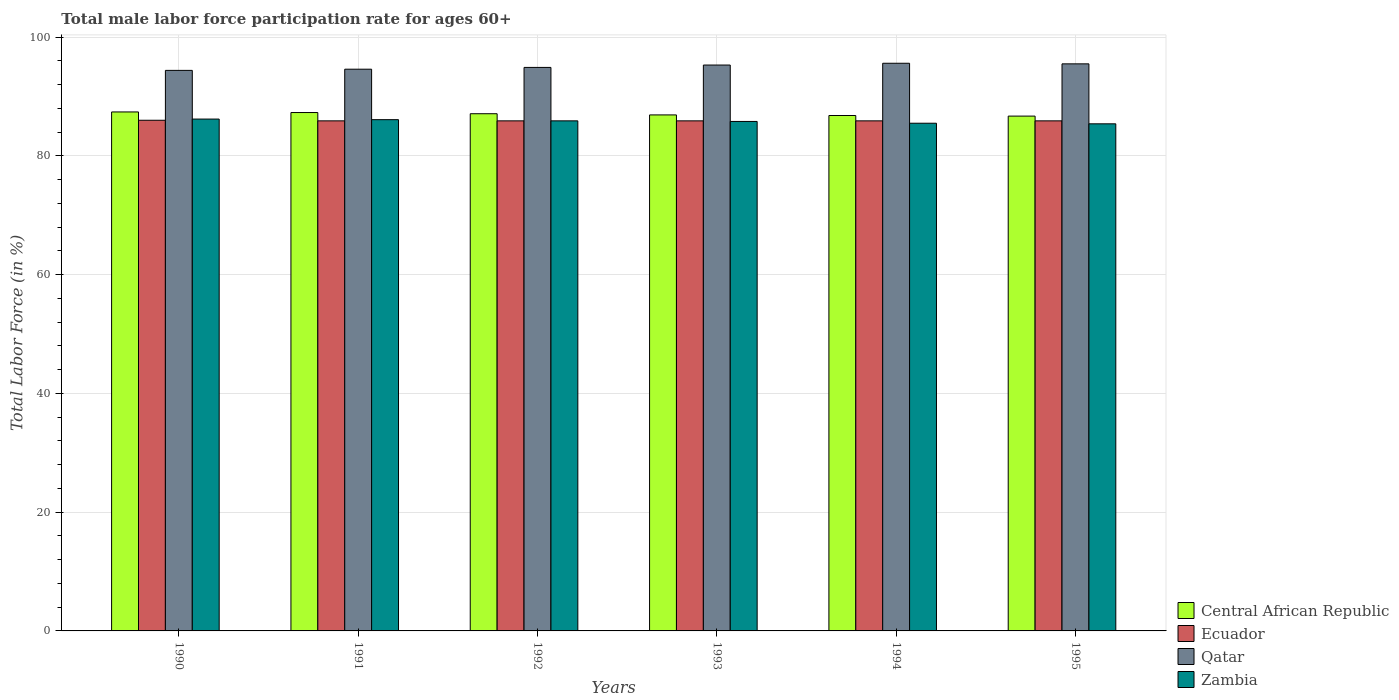How many different coloured bars are there?
Your response must be concise. 4. How many groups of bars are there?
Your response must be concise. 6. Are the number of bars per tick equal to the number of legend labels?
Your answer should be compact. Yes. Are the number of bars on each tick of the X-axis equal?
Your response must be concise. Yes. How many bars are there on the 3rd tick from the left?
Give a very brief answer. 4. What is the label of the 5th group of bars from the left?
Your answer should be very brief. 1994. What is the male labor force participation rate in Zambia in 1990?
Provide a succinct answer. 86.2. Across all years, what is the maximum male labor force participation rate in Central African Republic?
Provide a short and direct response. 87.4. Across all years, what is the minimum male labor force participation rate in Central African Republic?
Ensure brevity in your answer.  86.7. In which year was the male labor force participation rate in Central African Republic maximum?
Your answer should be very brief. 1990. In which year was the male labor force participation rate in Qatar minimum?
Your response must be concise. 1990. What is the total male labor force participation rate in Qatar in the graph?
Offer a very short reply. 570.3. What is the difference between the male labor force participation rate in Qatar in 1990 and that in 1994?
Offer a very short reply. -1.2. What is the average male labor force participation rate in Zambia per year?
Provide a succinct answer. 85.82. In the year 1992, what is the difference between the male labor force participation rate in Zambia and male labor force participation rate in Ecuador?
Offer a very short reply. 0. What is the ratio of the male labor force participation rate in Qatar in 1990 to that in 1991?
Give a very brief answer. 1. What is the difference between the highest and the second highest male labor force participation rate in Ecuador?
Provide a succinct answer. 0.1. What is the difference between the highest and the lowest male labor force participation rate in Zambia?
Your answer should be compact. 0.8. In how many years, is the male labor force participation rate in Qatar greater than the average male labor force participation rate in Qatar taken over all years?
Your answer should be compact. 3. Is the sum of the male labor force participation rate in Central African Republic in 1991 and 1995 greater than the maximum male labor force participation rate in Zambia across all years?
Ensure brevity in your answer.  Yes. What does the 2nd bar from the left in 1991 represents?
Keep it short and to the point. Ecuador. What does the 3rd bar from the right in 1991 represents?
Keep it short and to the point. Ecuador. How many bars are there?
Keep it short and to the point. 24. Are all the bars in the graph horizontal?
Provide a succinct answer. No. What is the difference between two consecutive major ticks on the Y-axis?
Ensure brevity in your answer.  20. Are the values on the major ticks of Y-axis written in scientific E-notation?
Keep it short and to the point. No. Does the graph contain any zero values?
Offer a very short reply. No. Where does the legend appear in the graph?
Your answer should be compact. Bottom right. How are the legend labels stacked?
Your response must be concise. Vertical. What is the title of the graph?
Your answer should be very brief. Total male labor force participation rate for ages 60+. Does "Israel" appear as one of the legend labels in the graph?
Keep it short and to the point. No. What is the label or title of the X-axis?
Provide a succinct answer. Years. What is the Total Labor Force (in %) of Central African Republic in 1990?
Make the answer very short. 87.4. What is the Total Labor Force (in %) in Ecuador in 1990?
Ensure brevity in your answer.  86. What is the Total Labor Force (in %) of Qatar in 1990?
Make the answer very short. 94.4. What is the Total Labor Force (in %) in Zambia in 1990?
Keep it short and to the point. 86.2. What is the Total Labor Force (in %) of Central African Republic in 1991?
Keep it short and to the point. 87.3. What is the Total Labor Force (in %) in Ecuador in 1991?
Your response must be concise. 85.9. What is the Total Labor Force (in %) in Qatar in 1991?
Make the answer very short. 94.6. What is the Total Labor Force (in %) in Zambia in 1991?
Your answer should be compact. 86.1. What is the Total Labor Force (in %) in Central African Republic in 1992?
Provide a succinct answer. 87.1. What is the Total Labor Force (in %) in Ecuador in 1992?
Your answer should be compact. 85.9. What is the Total Labor Force (in %) in Qatar in 1992?
Your response must be concise. 94.9. What is the Total Labor Force (in %) in Zambia in 1992?
Your answer should be very brief. 85.9. What is the Total Labor Force (in %) of Central African Republic in 1993?
Provide a succinct answer. 86.9. What is the Total Labor Force (in %) in Ecuador in 1993?
Your answer should be very brief. 85.9. What is the Total Labor Force (in %) in Qatar in 1993?
Give a very brief answer. 95.3. What is the Total Labor Force (in %) in Zambia in 1993?
Offer a terse response. 85.8. What is the Total Labor Force (in %) of Central African Republic in 1994?
Keep it short and to the point. 86.8. What is the Total Labor Force (in %) in Ecuador in 1994?
Make the answer very short. 85.9. What is the Total Labor Force (in %) in Qatar in 1994?
Give a very brief answer. 95.6. What is the Total Labor Force (in %) of Zambia in 1994?
Your response must be concise. 85.5. What is the Total Labor Force (in %) of Central African Republic in 1995?
Provide a short and direct response. 86.7. What is the Total Labor Force (in %) of Ecuador in 1995?
Offer a terse response. 85.9. What is the Total Labor Force (in %) of Qatar in 1995?
Make the answer very short. 95.5. What is the Total Labor Force (in %) of Zambia in 1995?
Keep it short and to the point. 85.4. Across all years, what is the maximum Total Labor Force (in %) of Central African Republic?
Your answer should be compact. 87.4. Across all years, what is the maximum Total Labor Force (in %) in Ecuador?
Your answer should be compact. 86. Across all years, what is the maximum Total Labor Force (in %) in Qatar?
Offer a very short reply. 95.6. Across all years, what is the maximum Total Labor Force (in %) of Zambia?
Offer a terse response. 86.2. Across all years, what is the minimum Total Labor Force (in %) of Central African Republic?
Your answer should be very brief. 86.7. Across all years, what is the minimum Total Labor Force (in %) of Ecuador?
Give a very brief answer. 85.9. Across all years, what is the minimum Total Labor Force (in %) in Qatar?
Provide a short and direct response. 94.4. Across all years, what is the minimum Total Labor Force (in %) of Zambia?
Your answer should be compact. 85.4. What is the total Total Labor Force (in %) in Central African Republic in the graph?
Offer a very short reply. 522.2. What is the total Total Labor Force (in %) of Ecuador in the graph?
Provide a short and direct response. 515.5. What is the total Total Labor Force (in %) of Qatar in the graph?
Keep it short and to the point. 570.3. What is the total Total Labor Force (in %) in Zambia in the graph?
Your answer should be very brief. 514.9. What is the difference between the Total Labor Force (in %) in Ecuador in 1990 and that in 1991?
Give a very brief answer. 0.1. What is the difference between the Total Labor Force (in %) in Ecuador in 1990 and that in 1992?
Your answer should be very brief. 0.1. What is the difference between the Total Labor Force (in %) in Central African Republic in 1990 and that in 1993?
Your answer should be compact. 0.5. What is the difference between the Total Labor Force (in %) in Ecuador in 1990 and that in 1993?
Give a very brief answer. 0.1. What is the difference between the Total Labor Force (in %) in Zambia in 1990 and that in 1993?
Keep it short and to the point. 0.4. What is the difference between the Total Labor Force (in %) of Qatar in 1990 and that in 1994?
Offer a very short reply. -1.2. What is the difference between the Total Labor Force (in %) of Central African Republic in 1990 and that in 1995?
Offer a terse response. 0.7. What is the difference between the Total Labor Force (in %) of Ecuador in 1990 and that in 1995?
Provide a short and direct response. 0.1. What is the difference between the Total Labor Force (in %) in Zambia in 1990 and that in 1995?
Offer a terse response. 0.8. What is the difference between the Total Labor Force (in %) of Central African Republic in 1991 and that in 1992?
Ensure brevity in your answer.  0.2. What is the difference between the Total Labor Force (in %) of Central African Republic in 1991 and that in 1993?
Provide a short and direct response. 0.4. What is the difference between the Total Labor Force (in %) in Ecuador in 1991 and that in 1993?
Keep it short and to the point. 0. What is the difference between the Total Labor Force (in %) of Central African Republic in 1991 and that in 1994?
Keep it short and to the point. 0.5. What is the difference between the Total Labor Force (in %) in Qatar in 1991 and that in 1994?
Offer a terse response. -1. What is the difference between the Total Labor Force (in %) in Zambia in 1991 and that in 1994?
Provide a short and direct response. 0.6. What is the difference between the Total Labor Force (in %) in Central African Republic in 1991 and that in 1995?
Offer a terse response. 0.6. What is the difference between the Total Labor Force (in %) in Zambia in 1991 and that in 1995?
Your response must be concise. 0.7. What is the difference between the Total Labor Force (in %) of Central African Republic in 1992 and that in 1993?
Ensure brevity in your answer.  0.2. What is the difference between the Total Labor Force (in %) in Ecuador in 1992 and that in 1993?
Your response must be concise. 0. What is the difference between the Total Labor Force (in %) of Qatar in 1992 and that in 1993?
Provide a succinct answer. -0.4. What is the difference between the Total Labor Force (in %) of Central African Republic in 1992 and that in 1994?
Your answer should be compact. 0.3. What is the difference between the Total Labor Force (in %) of Ecuador in 1992 and that in 1994?
Provide a short and direct response. 0. What is the difference between the Total Labor Force (in %) in Zambia in 1992 and that in 1994?
Provide a short and direct response. 0.4. What is the difference between the Total Labor Force (in %) of Central African Republic in 1992 and that in 1995?
Offer a terse response. 0.4. What is the difference between the Total Labor Force (in %) of Ecuador in 1992 and that in 1995?
Your response must be concise. 0. What is the difference between the Total Labor Force (in %) of Zambia in 1992 and that in 1995?
Your response must be concise. 0.5. What is the difference between the Total Labor Force (in %) of Zambia in 1993 and that in 1994?
Ensure brevity in your answer.  0.3. What is the difference between the Total Labor Force (in %) of Qatar in 1993 and that in 1995?
Your response must be concise. -0.2. What is the difference between the Total Labor Force (in %) in Zambia in 1993 and that in 1995?
Your answer should be compact. 0.4. What is the difference between the Total Labor Force (in %) of Central African Republic in 1990 and the Total Labor Force (in %) of Ecuador in 1991?
Your answer should be very brief. 1.5. What is the difference between the Total Labor Force (in %) of Central African Republic in 1990 and the Total Labor Force (in %) of Qatar in 1991?
Give a very brief answer. -7.2. What is the difference between the Total Labor Force (in %) in Central African Republic in 1990 and the Total Labor Force (in %) in Zambia in 1991?
Your response must be concise. 1.3. What is the difference between the Total Labor Force (in %) of Ecuador in 1990 and the Total Labor Force (in %) of Qatar in 1991?
Offer a terse response. -8.6. What is the difference between the Total Labor Force (in %) in Ecuador in 1990 and the Total Labor Force (in %) in Zambia in 1991?
Offer a terse response. -0.1. What is the difference between the Total Labor Force (in %) in Central African Republic in 1990 and the Total Labor Force (in %) in Qatar in 1992?
Your answer should be very brief. -7.5. What is the difference between the Total Labor Force (in %) in Central African Republic in 1990 and the Total Labor Force (in %) in Zambia in 1992?
Offer a very short reply. 1.5. What is the difference between the Total Labor Force (in %) in Ecuador in 1990 and the Total Labor Force (in %) in Qatar in 1992?
Give a very brief answer. -8.9. What is the difference between the Total Labor Force (in %) of Ecuador in 1990 and the Total Labor Force (in %) of Zambia in 1992?
Provide a succinct answer. 0.1. What is the difference between the Total Labor Force (in %) of Qatar in 1990 and the Total Labor Force (in %) of Zambia in 1992?
Your response must be concise. 8.5. What is the difference between the Total Labor Force (in %) in Central African Republic in 1990 and the Total Labor Force (in %) in Ecuador in 1993?
Your answer should be very brief. 1.5. What is the difference between the Total Labor Force (in %) of Central African Republic in 1990 and the Total Labor Force (in %) of Zambia in 1993?
Offer a terse response. 1.6. What is the difference between the Total Labor Force (in %) of Qatar in 1990 and the Total Labor Force (in %) of Zambia in 1993?
Your answer should be compact. 8.6. What is the difference between the Total Labor Force (in %) of Central African Republic in 1990 and the Total Labor Force (in %) of Qatar in 1994?
Make the answer very short. -8.2. What is the difference between the Total Labor Force (in %) of Central African Republic in 1990 and the Total Labor Force (in %) of Zambia in 1994?
Make the answer very short. 1.9. What is the difference between the Total Labor Force (in %) in Ecuador in 1990 and the Total Labor Force (in %) in Qatar in 1994?
Provide a succinct answer. -9.6. What is the difference between the Total Labor Force (in %) in Ecuador in 1990 and the Total Labor Force (in %) in Zambia in 1994?
Provide a succinct answer. 0.5. What is the difference between the Total Labor Force (in %) of Qatar in 1990 and the Total Labor Force (in %) of Zambia in 1994?
Keep it short and to the point. 8.9. What is the difference between the Total Labor Force (in %) in Ecuador in 1990 and the Total Labor Force (in %) in Qatar in 1995?
Your answer should be compact. -9.5. What is the difference between the Total Labor Force (in %) in Ecuador in 1990 and the Total Labor Force (in %) in Zambia in 1995?
Make the answer very short. 0.6. What is the difference between the Total Labor Force (in %) of Qatar in 1990 and the Total Labor Force (in %) of Zambia in 1995?
Ensure brevity in your answer.  9. What is the difference between the Total Labor Force (in %) in Central African Republic in 1991 and the Total Labor Force (in %) in Ecuador in 1992?
Make the answer very short. 1.4. What is the difference between the Total Labor Force (in %) of Central African Republic in 1991 and the Total Labor Force (in %) of Qatar in 1992?
Your answer should be very brief. -7.6. What is the difference between the Total Labor Force (in %) in Central African Republic in 1991 and the Total Labor Force (in %) in Zambia in 1992?
Your response must be concise. 1.4. What is the difference between the Total Labor Force (in %) in Ecuador in 1991 and the Total Labor Force (in %) in Qatar in 1992?
Your answer should be very brief. -9. What is the difference between the Total Labor Force (in %) of Central African Republic in 1991 and the Total Labor Force (in %) of Qatar in 1993?
Offer a very short reply. -8. What is the difference between the Total Labor Force (in %) of Ecuador in 1991 and the Total Labor Force (in %) of Qatar in 1993?
Provide a succinct answer. -9.4. What is the difference between the Total Labor Force (in %) of Ecuador in 1991 and the Total Labor Force (in %) of Zambia in 1993?
Your answer should be compact. 0.1. What is the difference between the Total Labor Force (in %) in Central African Republic in 1991 and the Total Labor Force (in %) in Ecuador in 1994?
Offer a terse response. 1.4. What is the difference between the Total Labor Force (in %) of Central African Republic in 1991 and the Total Labor Force (in %) of Qatar in 1994?
Provide a short and direct response. -8.3. What is the difference between the Total Labor Force (in %) of Central African Republic in 1991 and the Total Labor Force (in %) of Zambia in 1994?
Your response must be concise. 1.8. What is the difference between the Total Labor Force (in %) in Ecuador in 1991 and the Total Labor Force (in %) in Qatar in 1994?
Provide a short and direct response. -9.7. What is the difference between the Total Labor Force (in %) of Central African Republic in 1991 and the Total Labor Force (in %) of Qatar in 1995?
Keep it short and to the point. -8.2. What is the difference between the Total Labor Force (in %) in Ecuador in 1991 and the Total Labor Force (in %) in Qatar in 1995?
Offer a very short reply. -9.6. What is the difference between the Total Labor Force (in %) of Qatar in 1991 and the Total Labor Force (in %) of Zambia in 1995?
Your answer should be compact. 9.2. What is the difference between the Total Labor Force (in %) in Central African Republic in 1992 and the Total Labor Force (in %) in Zambia in 1994?
Offer a terse response. 1.6. What is the difference between the Total Labor Force (in %) in Central African Republic in 1992 and the Total Labor Force (in %) in Ecuador in 1995?
Offer a very short reply. 1.2. What is the difference between the Total Labor Force (in %) of Central African Republic in 1992 and the Total Labor Force (in %) of Qatar in 1995?
Ensure brevity in your answer.  -8.4. What is the difference between the Total Labor Force (in %) of Central African Republic in 1992 and the Total Labor Force (in %) of Zambia in 1995?
Ensure brevity in your answer.  1.7. What is the difference between the Total Labor Force (in %) in Central African Republic in 1993 and the Total Labor Force (in %) in Qatar in 1994?
Offer a very short reply. -8.7. What is the difference between the Total Labor Force (in %) of Central African Republic in 1993 and the Total Labor Force (in %) of Zambia in 1994?
Your answer should be very brief. 1.4. What is the difference between the Total Labor Force (in %) in Qatar in 1993 and the Total Labor Force (in %) in Zambia in 1994?
Your response must be concise. 9.8. What is the difference between the Total Labor Force (in %) in Central African Republic in 1993 and the Total Labor Force (in %) in Ecuador in 1995?
Make the answer very short. 1. What is the difference between the Total Labor Force (in %) in Central African Republic in 1993 and the Total Labor Force (in %) in Qatar in 1995?
Make the answer very short. -8.6. What is the difference between the Total Labor Force (in %) in Central African Republic in 1993 and the Total Labor Force (in %) in Zambia in 1995?
Make the answer very short. 1.5. What is the difference between the Total Labor Force (in %) of Ecuador in 1993 and the Total Labor Force (in %) of Zambia in 1995?
Your answer should be very brief. 0.5. What is the difference between the Total Labor Force (in %) of Qatar in 1993 and the Total Labor Force (in %) of Zambia in 1995?
Make the answer very short. 9.9. What is the difference between the Total Labor Force (in %) in Central African Republic in 1994 and the Total Labor Force (in %) in Zambia in 1995?
Provide a succinct answer. 1.4. What is the difference between the Total Labor Force (in %) in Ecuador in 1994 and the Total Labor Force (in %) in Qatar in 1995?
Provide a short and direct response. -9.6. What is the difference between the Total Labor Force (in %) of Ecuador in 1994 and the Total Labor Force (in %) of Zambia in 1995?
Offer a terse response. 0.5. What is the difference between the Total Labor Force (in %) in Qatar in 1994 and the Total Labor Force (in %) in Zambia in 1995?
Provide a short and direct response. 10.2. What is the average Total Labor Force (in %) of Central African Republic per year?
Your answer should be very brief. 87.03. What is the average Total Labor Force (in %) in Ecuador per year?
Give a very brief answer. 85.92. What is the average Total Labor Force (in %) of Qatar per year?
Ensure brevity in your answer.  95.05. What is the average Total Labor Force (in %) of Zambia per year?
Your response must be concise. 85.82. In the year 1990, what is the difference between the Total Labor Force (in %) of Qatar and Total Labor Force (in %) of Zambia?
Your answer should be very brief. 8.2. In the year 1991, what is the difference between the Total Labor Force (in %) of Central African Republic and Total Labor Force (in %) of Ecuador?
Your answer should be compact. 1.4. In the year 1991, what is the difference between the Total Labor Force (in %) in Central African Republic and Total Labor Force (in %) in Qatar?
Offer a very short reply. -7.3. In the year 1991, what is the difference between the Total Labor Force (in %) in Central African Republic and Total Labor Force (in %) in Zambia?
Your answer should be very brief. 1.2. In the year 1992, what is the difference between the Total Labor Force (in %) in Central African Republic and Total Labor Force (in %) in Zambia?
Provide a succinct answer. 1.2. In the year 1992, what is the difference between the Total Labor Force (in %) in Ecuador and Total Labor Force (in %) in Zambia?
Ensure brevity in your answer.  0. In the year 1992, what is the difference between the Total Labor Force (in %) in Qatar and Total Labor Force (in %) in Zambia?
Your response must be concise. 9. In the year 1993, what is the difference between the Total Labor Force (in %) in Ecuador and Total Labor Force (in %) in Zambia?
Make the answer very short. 0.1. In the year 1993, what is the difference between the Total Labor Force (in %) in Qatar and Total Labor Force (in %) in Zambia?
Offer a terse response. 9.5. In the year 1994, what is the difference between the Total Labor Force (in %) in Central African Republic and Total Labor Force (in %) in Ecuador?
Ensure brevity in your answer.  0.9. In the year 1994, what is the difference between the Total Labor Force (in %) of Central African Republic and Total Labor Force (in %) of Qatar?
Ensure brevity in your answer.  -8.8. In the year 1994, what is the difference between the Total Labor Force (in %) of Central African Republic and Total Labor Force (in %) of Zambia?
Offer a very short reply. 1.3. In the year 1994, what is the difference between the Total Labor Force (in %) of Ecuador and Total Labor Force (in %) of Qatar?
Your answer should be very brief. -9.7. In the year 1994, what is the difference between the Total Labor Force (in %) of Qatar and Total Labor Force (in %) of Zambia?
Keep it short and to the point. 10.1. In the year 1995, what is the difference between the Total Labor Force (in %) of Ecuador and Total Labor Force (in %) of Qatar?
Ensure brevity in your answer.  -9.6. What is the ratio of the Total Labor Force (in %) in Central African Republic in 1990 to that in 1991?
Your answer should be compact. 1. What is the ratio of the Total Labor Force (in %) in Qatar in 1990 to that in 1991?
Keep it short and to the point. 1. What is the ratio of the Total Labor Force (in %) in Ecuador in 1990 to that in 1992?
Offer a terse response. 1. What is the ratio of the Total Labor Force (in %) in Qatar in 1990 to that in 1993?
Make the answer very short. 0.99. What is the ratio of the Total Labor Force (in %) of Zambia in 1990 to that in 1993?
Your answer should be very brief. 1. What is the ratio of the Total Labor Force (in %) in Central African Republic in 1990 to that in 1994?
Make the answer very short. 1.01. What is the ratio of the Total Labor Force (in %) of Qatar in 1990 to that in 1994?
Offer a terse response. 0.99. What is the ratio of the Total Labor Force (in %) in Zambia in 1990 to that in 1994?
Keep it short and to the point. 1.01. What is the ratio of the Total Labor Force (in %) of Ecuador in 1990 to that in 1995?
Give a very brief answer. 1. What is the ratio of the Total Labor Force (in %) of Zambia in 1990 to that in 1995?
Your response must be concise. 1.01. What is the ratio of the Total Labor Force (in %) in Ecuador in 1991 to that in 1992?
Make the answer very short. 1. What is the ratio of the Total Labor Force (in %) in Central African Republic in 1991 to that in 1993?
Give a very brief answer. 1. What is the ratio of the Total Labor Force (in %) of Ecuador in 1991 to that in 1993?
Make the answer very short. 1. What is the ratio of the Total Labor Force (in %) of Zambia in 1991 to that in 1993?
Your answer should be compact. 1. What is the ratio of the Total Labor Force (in %) of Ecuador in 1991 to that in 1994?
Your answer should be very brief. 1. What is the ratio of the Total Labor Force (in %) in Qatar in 1991 to that in 1994?
Offer a terse response. 0.99. What is the ratio of the Total Labor Force (in %) in Zambia in 1991 to that in 1994?
Provide a short and direct response. 1.01. What is the ratio of the Total Labor Force (in %) of Ecuador in 1991 to that in 1995?
Offer a very short reply. 1. What is the ratio of the Total Labor Force (in %) of Qatar in 1991 to that in 1995?
Ensure brevity in your answer.  0.99. What is the ratio of the Total Labor Force (in %) in Zambia in 1991 to that in 1995?
Make the answer very short. 1.01. What is the ratio of the Total Labor Force (in %) of Central African Republic in 1992 to that in 1993?
Provide a short and direct response. 1. What is the ratio of the Total Labor Force (in %) of Ecuador in 1992 to that in 1993?
Your response must be concise. 1. What is the ratio of the Total Labor Force (in %) in Qatar in 1992 to that in 1993?
Provide a succinct answer. 1. What is the ratio of the Total Labor Force (in %) in Central African Republic in 1992 to that in 1994?
Ensure brevity in your answer.  1. What is the ratio of the Total Labor Force (in %) of Qatar in 1992 to that in 1994?
Provide a succinct answer. 0.99. What is the ratio of the Total Labor Force (in %) of Zambia in 1992 to that in 1994?
Offer a very short reply. 1. What is the ratio of the Total Labor Force (in %) in Zambia in 1992 to that in 1995?
Your response must be concise. 1.01. What is the ratio of the Total Labor Force (in %) of Central African Republic in 1993 to that in 1994?
Keep it short and to the point. 1. What is the ratio of the Total Labor Force (in %) of Ecuador in 1993 to that in 1994?
Provide a short and direct response. 1. What is the ratio of the Total Labor Force (in %) of Zambia in 1993 to that in 1994?
Offer a terse response. 1. What is the ratio of the Total Labor Force (in %) of Central African Republic in 1993 to that in 1995?
Your answer should be compact. 1. What is the ratio of the Total Labor Force (in %) of Qatar in 1993 to that in 1995?
Give a very brief answer. 1. What is the ratio of the Total Labor Force (in %) of Zambia in 1993 to that in 1995?
Give a very brief answer. 1. What is the difference between the highest and the lowest Total Labor Force (in %) of Ecuador?
Ensure brevity in your answer.  0.1. What is the difference between the highest and the lowest Total Labor Force (in %) of Qatar?
Ensure brevity in your answer.  1.2. 